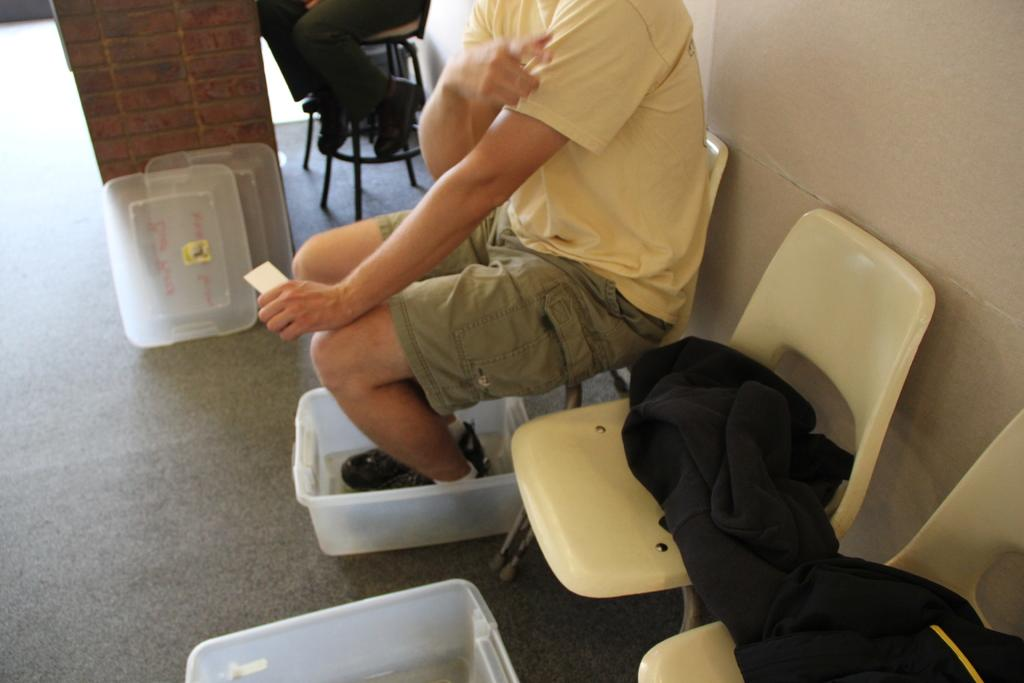What is the main subject in the image? There is a person sitting on a chair in the image. What can be seen in the background of the image? There is a pillar and a stool in the background of the image. Are there any other people visible in the image? Yes, some person's legs are visible in the background of the image. What type of apparel is the fly wearing in the image? There is no fly present in the image, so it is not possible to determine what apparel it might be wearing. 